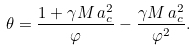<formula> <loc_0><loc_0><loc_500><loc_500>\theta = { \frac { { 1 + \gamma M \, a _ { c } ^ { 2 } } } { \varphi } } - { \frac { { \gamma M \, a _ { c } ^ { 2 } } } { { \varphi ^ { 2 } } } } .</formula> 